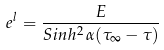Convert formula to latex. <formula><loc_0><loc_0><loc_500><loc_500>e ^ { l } = \frac { E } { S i n h ^ { 2 } \, \alpha ( \tau _ { \infty } - \tau ) }</formula> 